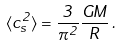<formula> <loc_0><loc_0><loc_500><loc_500>\langle c _ { s } ^ { 2 } \rangle = \frac { 3 } { \pi ^ { 2 } } \frac { G M } { R } \, .</formula> 